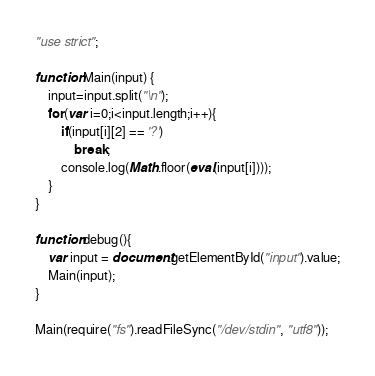Convert code to text. <code><loc_0><loc_0><loc_500><loc_500><_JavaScript_>"use strict";

function Main(input) {
    input=input.split("\n");
    for(var i=0;i<input.length;i++){
        if(input[i][2] == '?')
            break;
        console.log(Math.floor(eval(input[i])));
    }
}
    
function debug(){
	var input = document.getElementById("input").value;
	Main(input);
}

Main(require("fs").readFileSync("/dev/stdin", "utf8"));</code> 